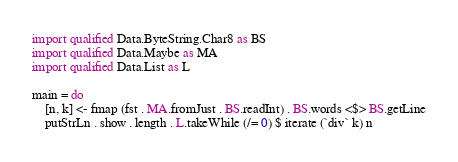Convert code to text. <code><loc_0><loc_0><loc_500><loc_500><_Haskell_>import qualified Data.ByteString.Char8 as BS
import qualified Data.Maybe as MA
import qualified Data.List as L

main = do
    [n, k] <- fmap (fst . MA.fromJust . BS.readInt) . BS.words <$> BS.getLine
    putStrLn . show . length . L.takeWhile (/= 0) $ iterate (`div` k) n
</code> 